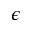<formula> <loc_0><loc_0><loc_500><loc_500>\epsilon</formula> 